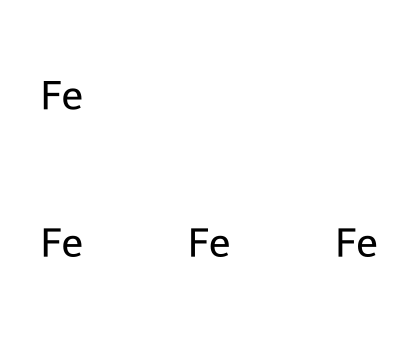What element is represented in this structure? The chemical structure shows the SMILES notation for iron, indicated by the symbol "Fe." The letters represent the element in the periodic table.
Answer: iron How many iron atoms are in this structure? Counting the notation "[Fe]" in the SMILES, there are four instances of "[Fe]," meaning there are four iron atoms represented in this structure.
Answer: four What type of bonding is likely present in the arrangement of iron? Iron typically exhibits metallic bonding, characterized by a sea of delocalized electrons among a lattice of positively charged iron ions. While the SMILES does not detail bonds, metals like iron are known for this bonding type.
Answer: metallic Is this arrangement likely to be solid, liquid, or gas at room temperature? Given that iron is a metal, and metals are solid at room temperature, this arrangement would be expected to be solid.
Answer: solid What is the primary use of iron in playground equipment? Iron is primarily used in playground equipment for its durability and strength, making it suitable for structures that need to endure significant use and weight without breaking down.
Answer: durability 